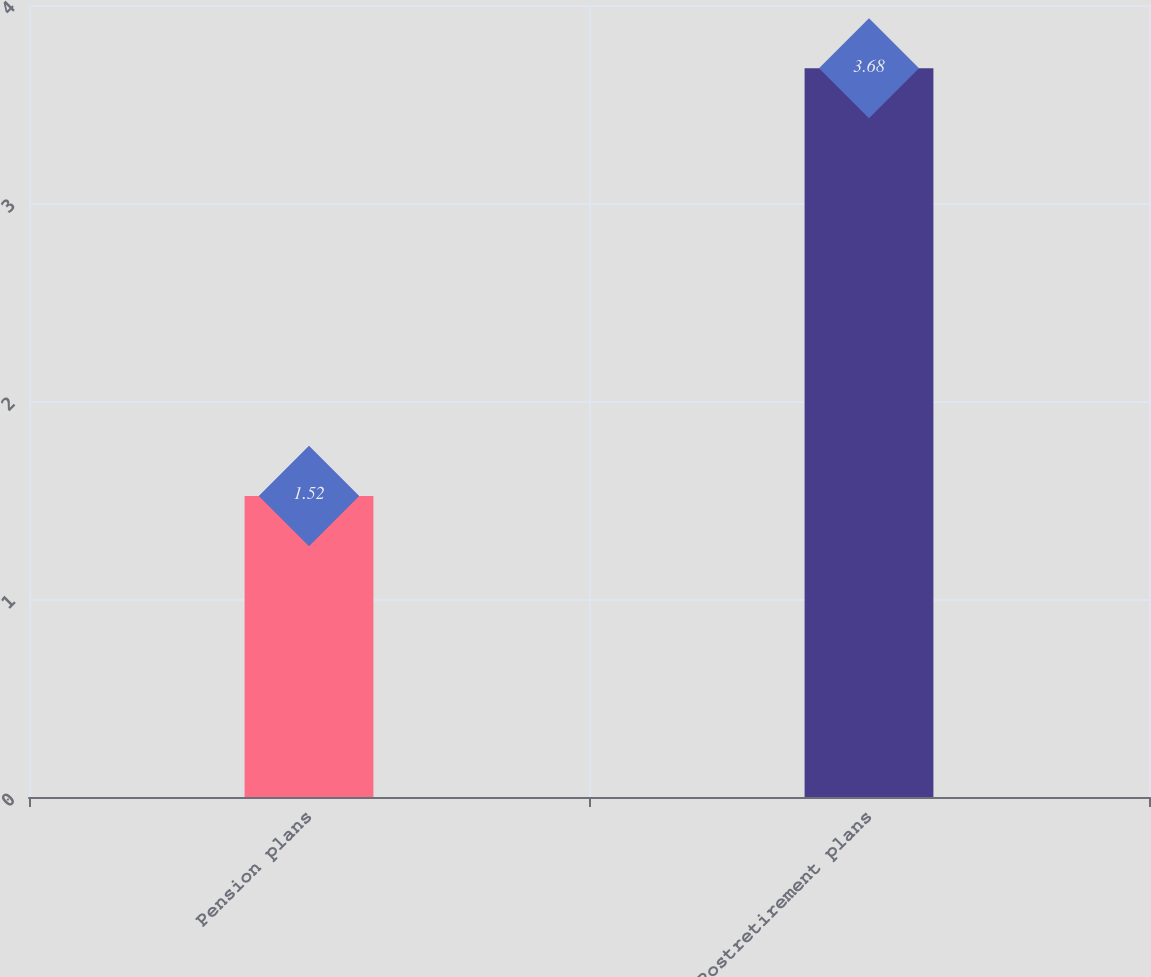<chart> <loc_0><loc_0><loc_500><loc_500><bar_chart><fcel>Pension plans<fcel>Postretirement plans<nl><fcel>1.52<fcel>3.68<nl></chart> 